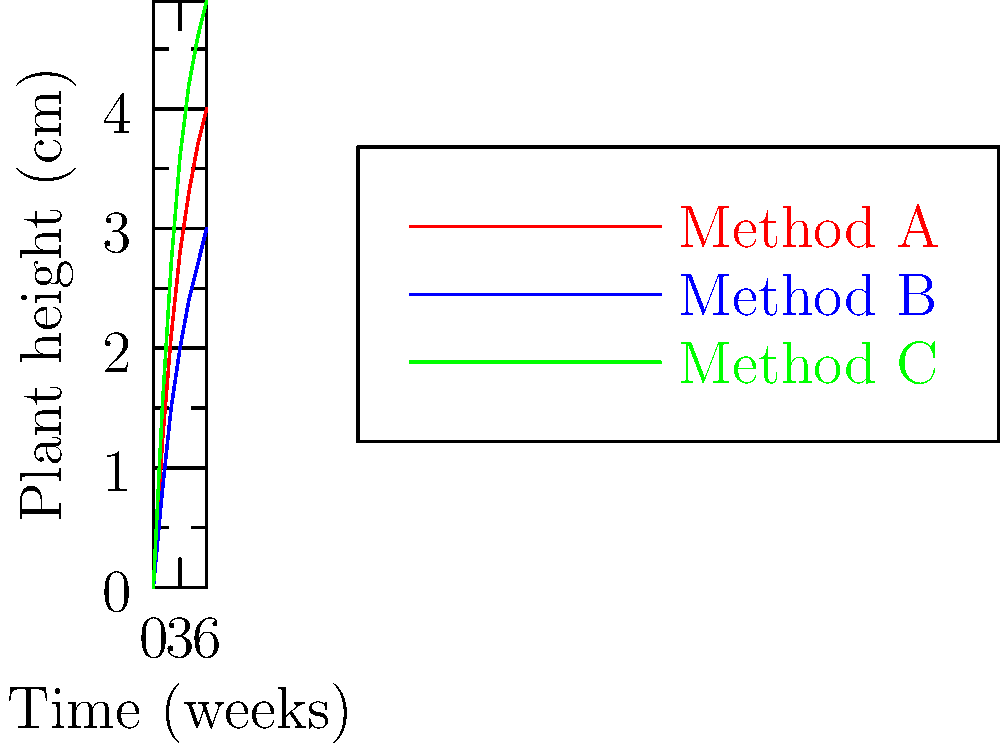Based on the growth curves shown in the graph, which cultivation method results in the fastest initial growth rate for the botanical species being studied, and what is the approximate height difference (in cm) between the best and worst performing methods after 3 weeks? To answer this question, we need to analyze the growth curves for each cultivation method:

1. Identify the methods:
   - Red line: Method A
   - Blue line: Method B
   - Green line: Method C

2. Determine the fastest initial growth rate:
   - Look at the steepness of each curve in the first few weeks.
   - Method C (green line) has the steepest initial slope, indicating the fastest initial growth rate.

3. Calculate the height difference after 3 weeks:
   - At the 3-week mark (x-axis):
     Method A (red): $\approx 2.8$ cm
     Method B (blue): $\approx 2.0$ cm
     Method C (green): $\approx 3.6$ cm
   - Best performing: Method C ($3.6$ cm)
   - Worst performing: Method B ($2.0$ cm)
   - Height difference: $3.6 - 2.0 = 1.6$ cm

Therefore, Method C results in the fastest initial growth rate, and the approximate height difference between the best (C) and worst (B) performing methods after 3 weeks is 1.6 cm.
Answer: Method C; 1.6 cm 